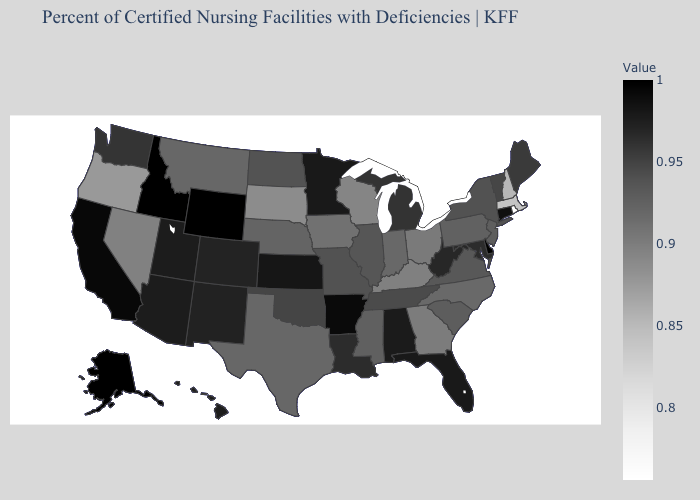Which states hav the highest value in the South?
Keep it brief. Delaware. Which states have the highest value in the USA?
Answer briefly. Alaska, Delaware, Idaho, Wyoming. Does Rhode Island have the lowest value in the USA?
Keep it brief. Yes. Is the legend a continuous bar?
Short answer required. Yes. Which states have the lowest value in the USA?
Quick response, please. Rhode Island. Which states have the highest value in the USA?
Give a very brief answer. Alaska, Delaware, Idaho, Wyoming. Is the legend a continuous bar?
Short answer required. Yes. Does California have a lower value than Indiana?
Be succinct. No. 